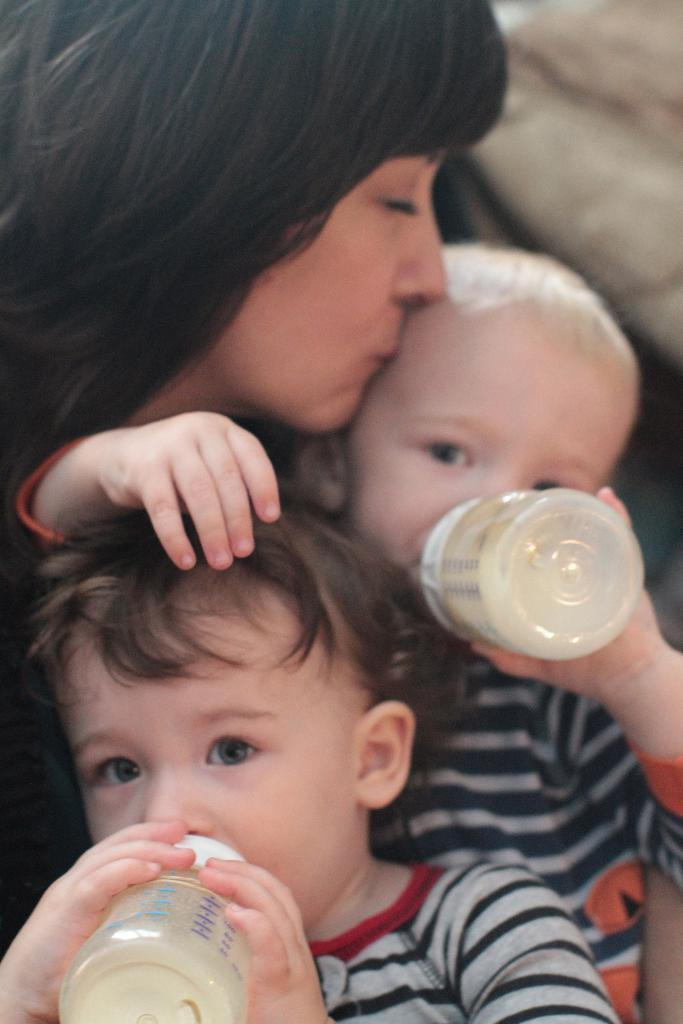Who is in the image? There is a lady in the image. What is the lady doing in the image? The lady is kissing a baby. How many babies are in the image? There are two babies in the image. What are the babies holding in their hands? Each baby has a feeding bottle in their hands. What type of meat is being served to the babies in the image? There is no meat present in the image; the babies are holding feeding bottles. Is there a clover plant visible in the image? There is no clover plant present in the image. 